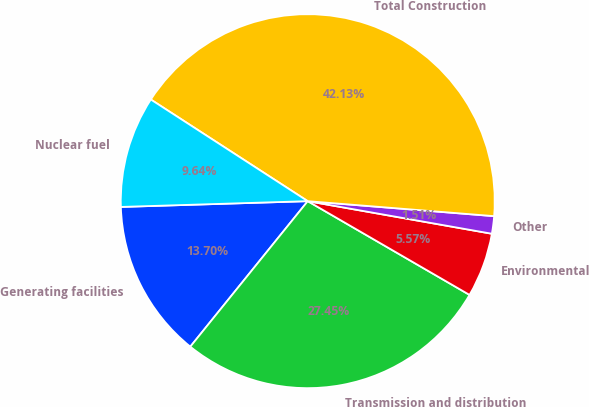<chart> <loc_0><loc_0><loc_500><loc_500><pie_chart><fcel>Generating facilities<fcel>Transmission and distribution<fcel>Environmental<fcel>Other<fcel>Total Construction<fcel>Nuclear fuel<nl><fcel>13.7%<fcel>27.45%<fcel>5.57%<fcel>1.51%<fcel>42.13%<fcel>9.64%<nl></chart> 